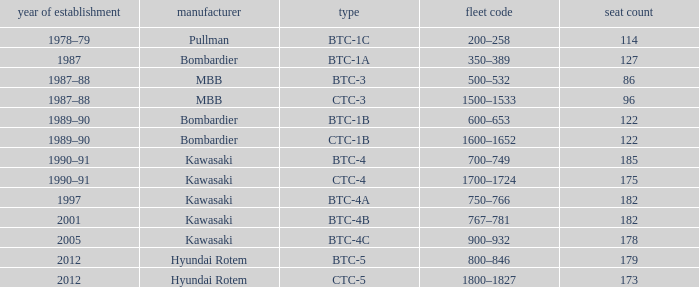In what year was the ctc-3 model built? 1987–88. 